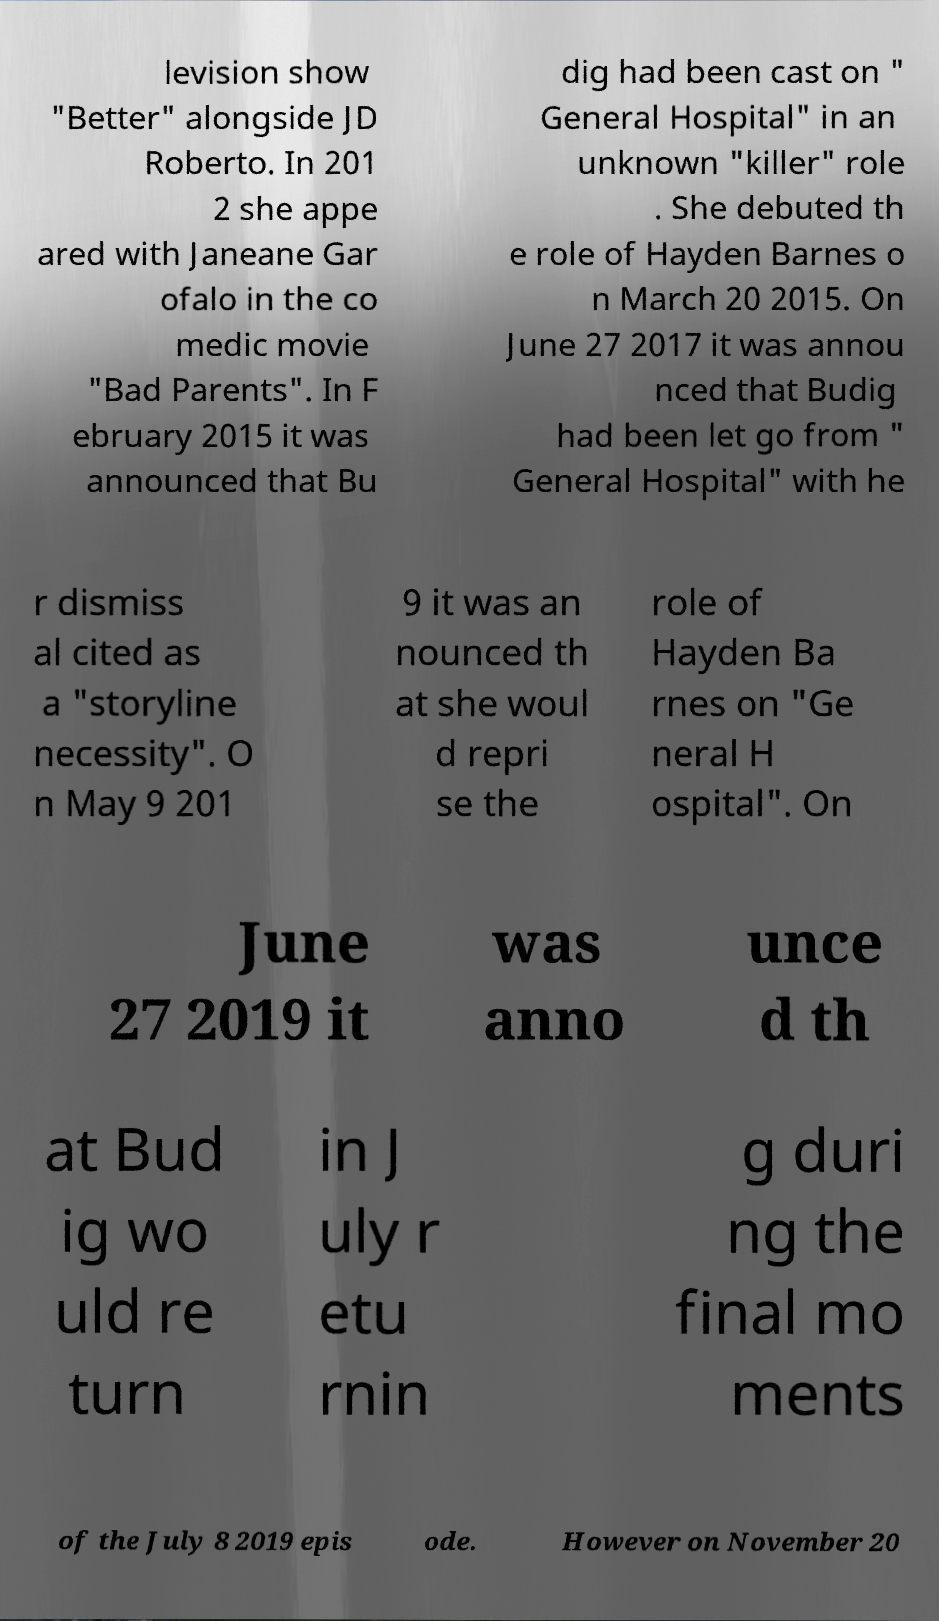Please identify and transcribe the text found in this image. levision show "Better" alongside JD Roberto. In 201 2 she appe ared with Janeane Gar ofalo in the co medic movie "Bad Parents". In F ebruary 2015 it was announced that Bu dig had been cast on " General Hospital" in an unknown "killer" role . She debuted th e role of Hayden Barnes o n March 20 2015. On June 27 2017 it was annou nced that Budig had been let go from " General Hospital" with he r dismiss al cited as a "storyline necessity". O n May 9 201 9 it was an nounced th at she woul d repri se the role of Hayden Ba rnes on "Ge neral H ospital". On June 27 2019 it was anno unce d th at Bud ig wo uld re turn in J uly r etu rnin g duri ng the final mo ments of the July 8 2019 epis ode. However on November 20 